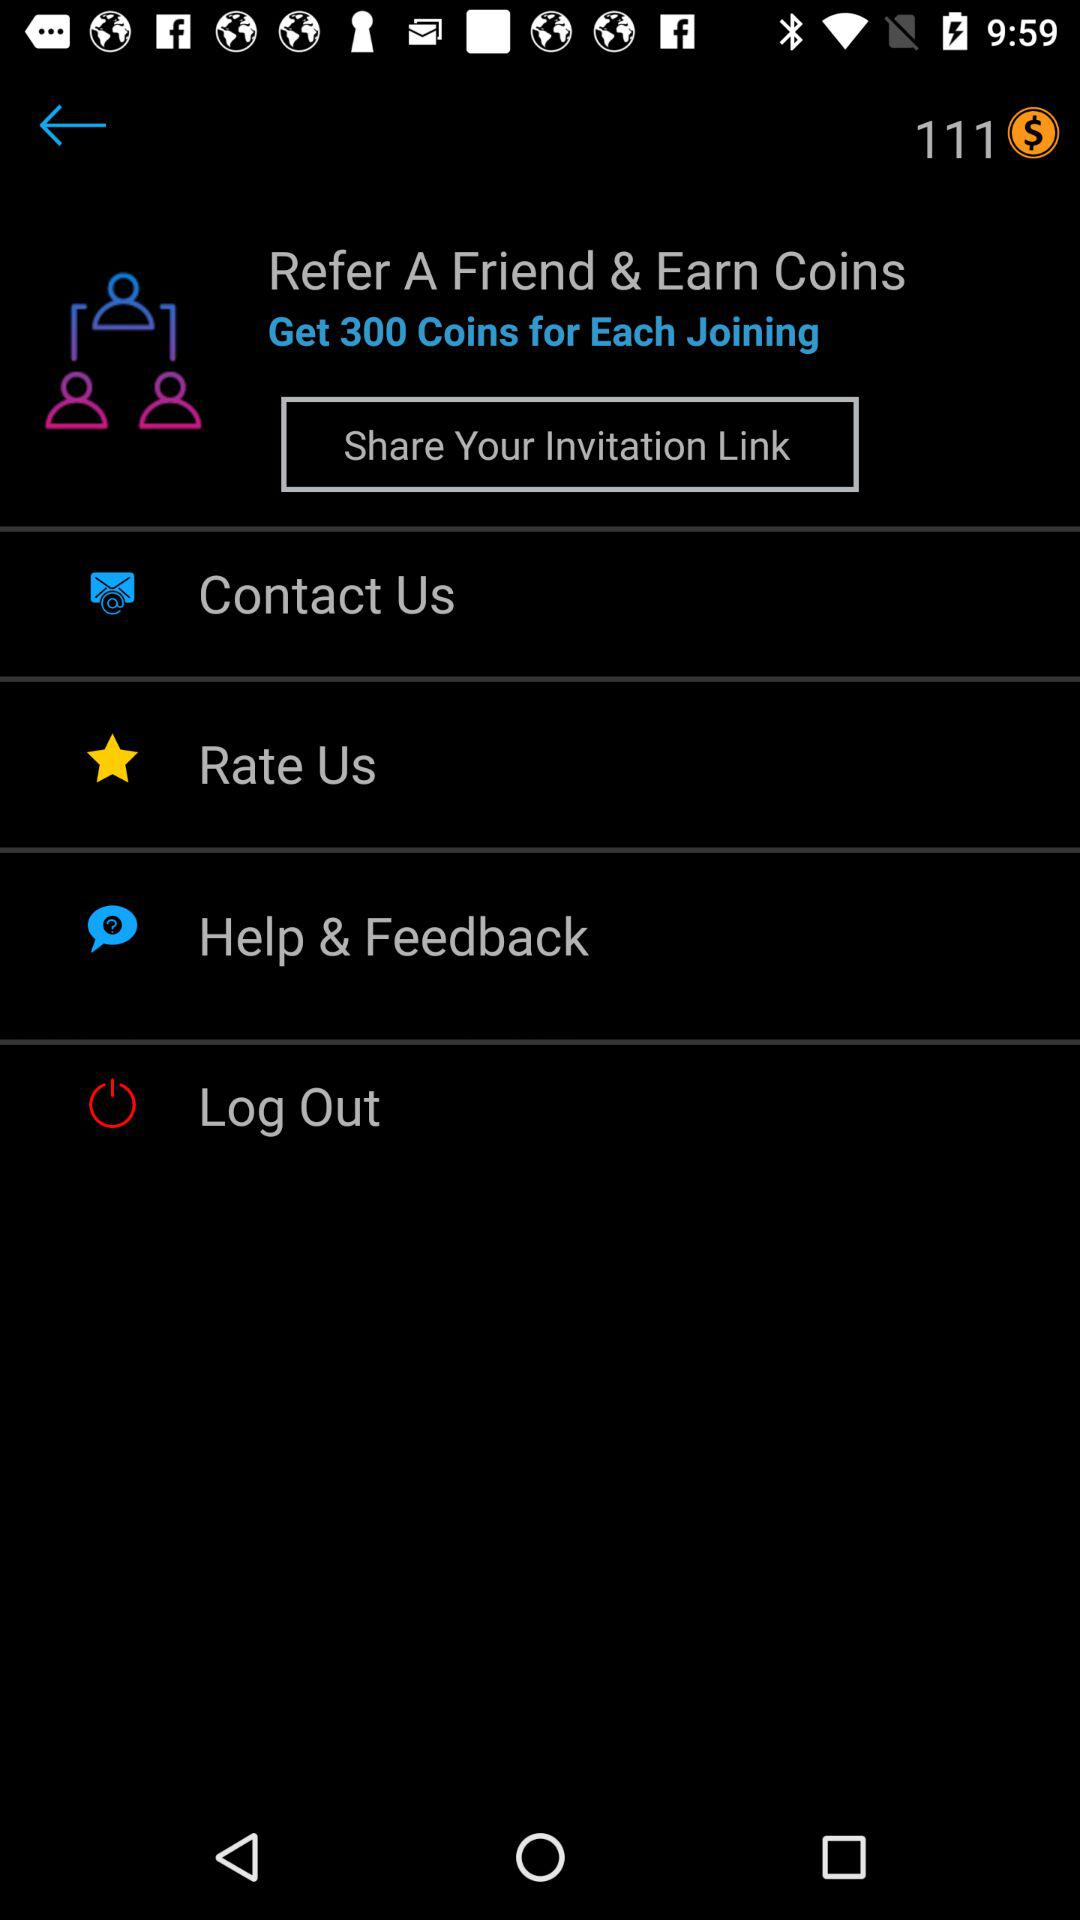How many coins can be earned on each joining by referring a friend? The number of coins that can be earned is 300. 